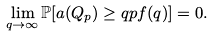Convert formula to latex. <formula><loc_0><loc_0><loc_500><loc_500>\lim _ { q \rightarrow \infty } \mathbb { P } [ a ( Q _ { p } ) \geq q p f ( q ) ] = 0 .</formula> 